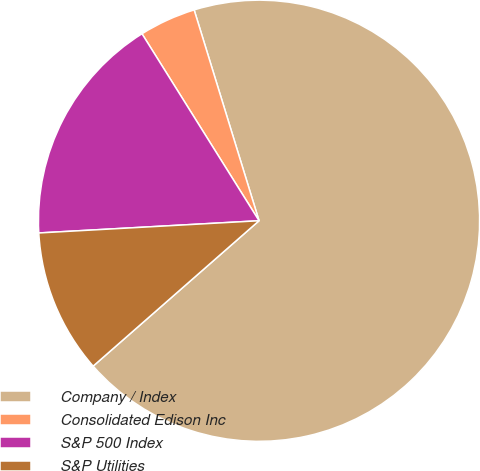Convert chart to OTSL. <chart><loc_0><loc_0><loc_500><loc_500><pie_chart><fcel>Company / Index<fcel>Consolidated Edison Inc<fcel>S&P 500 Index<fcel>S&P Utilities<nl><fcel>68.3%<fcel>4.15%<fcel>16.98%<fcel>10.57%<nl></chart> 